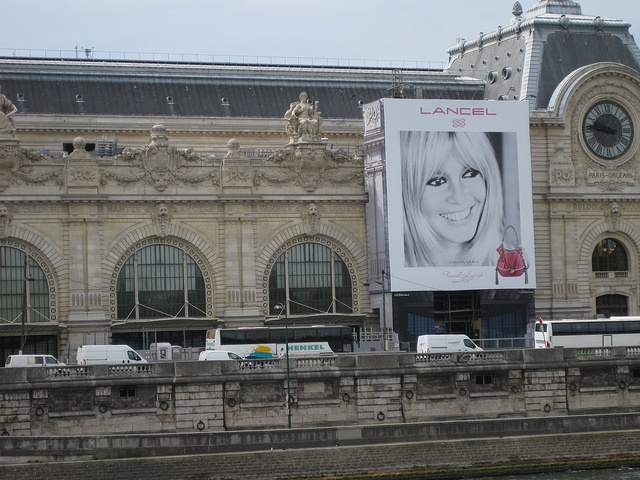Describe the objects in this image and their specific colors. I can see bus in lightgray, black, darkgray, and gray tones, bus in lightgray, darkgray, black, and gray tones, clock in lightgray, black, gray, and purple tones, truck in lightgray, darkgray, and gray tones, and handbag in lightgray, darkgray, brown, gray, and purple tones in this image. 